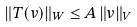<formula> <loc_0><loc_0><loc_500><loc_500>\| T ( v ) \| _ { W } \leq A \, \| v \| _ { V }</formula> 